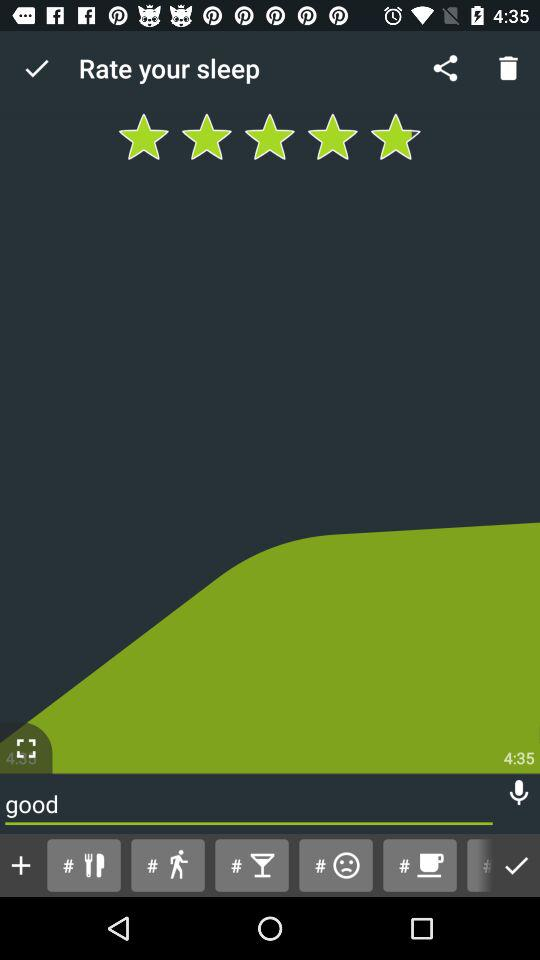Who is this application powered by?
When the provided information is insufficient, respond with <no answer>. <no answer> 